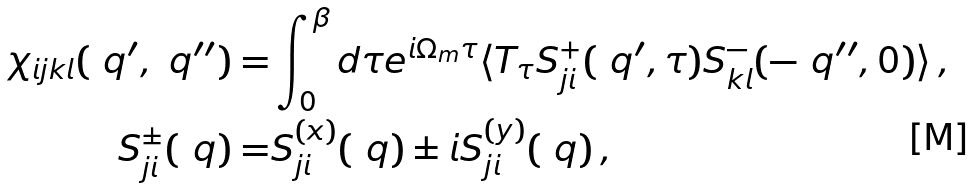Convert formula to latex. <formula><loc_0><loc_0><loc_500><loc_500>\chi _ { i j k l } ( \ q ^ { \prime } , \ q ^ { \prime \prime } ) = & \int _ { 0 } ^ { \beta } d \tau e ^ { i \Omega _ { m } \tau } \langle T _ { \tau } S _ { j i } ^ { + } ( \ q ^ { \prime } , \tau ) S _ { k l } ^ { - } ( - \ q ^ { \prime \prime } , 0 ) \rangle \, , \\ S _ { j i } ^ { \pm } ( \ q ) = & S _ { j i } ^ { ( x ) } ( \ q ) \pm i S _ { j i } ^ { ( y ) } ( \ q ) \, ,</formula> 